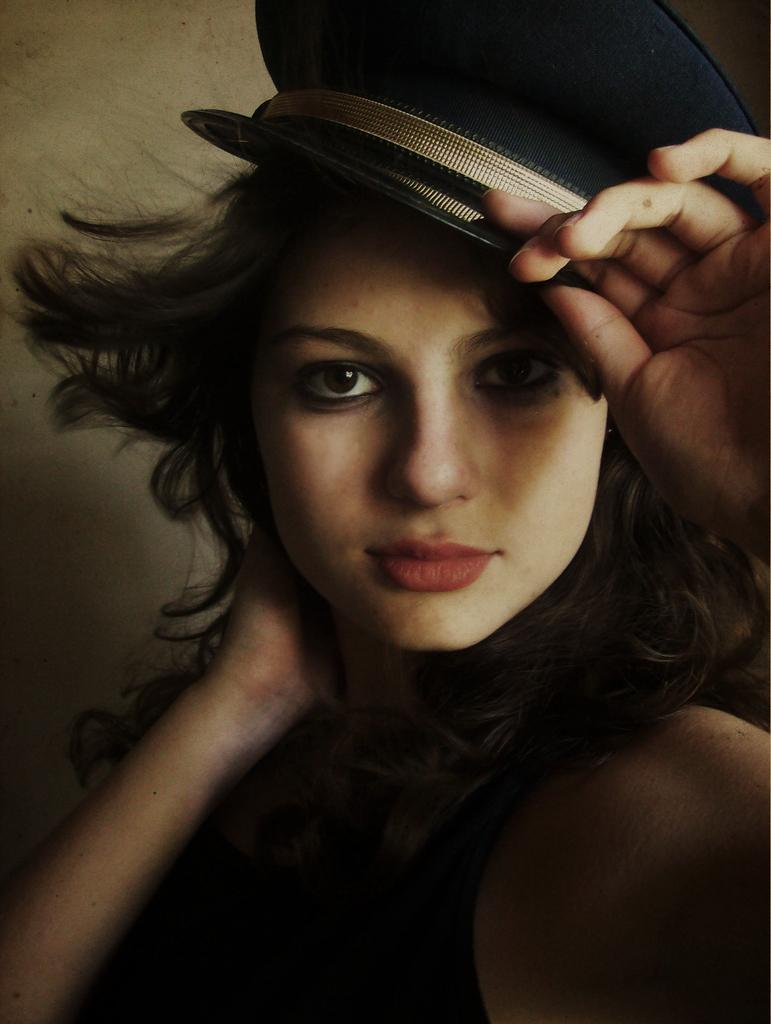In one or two sentences, can you explain what this image depicts? In this image, we can see a woman in black dress wearing a cap and seeing. Background there is a wall. 